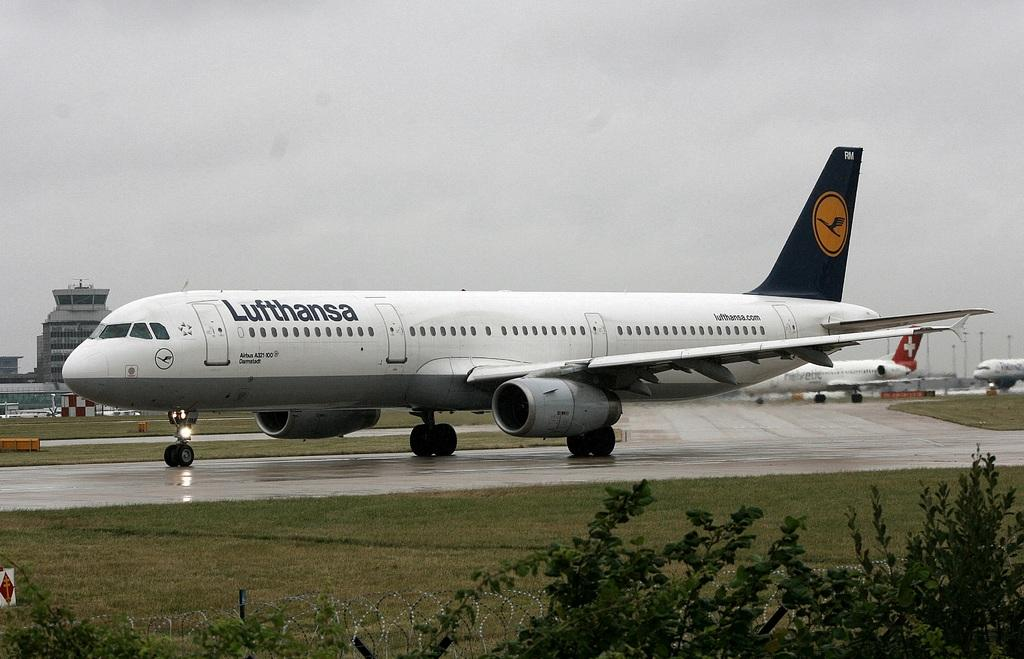Provide a one-sentence caption for the provided image. A Lufthansa plane is on the runway on an overcast day. 